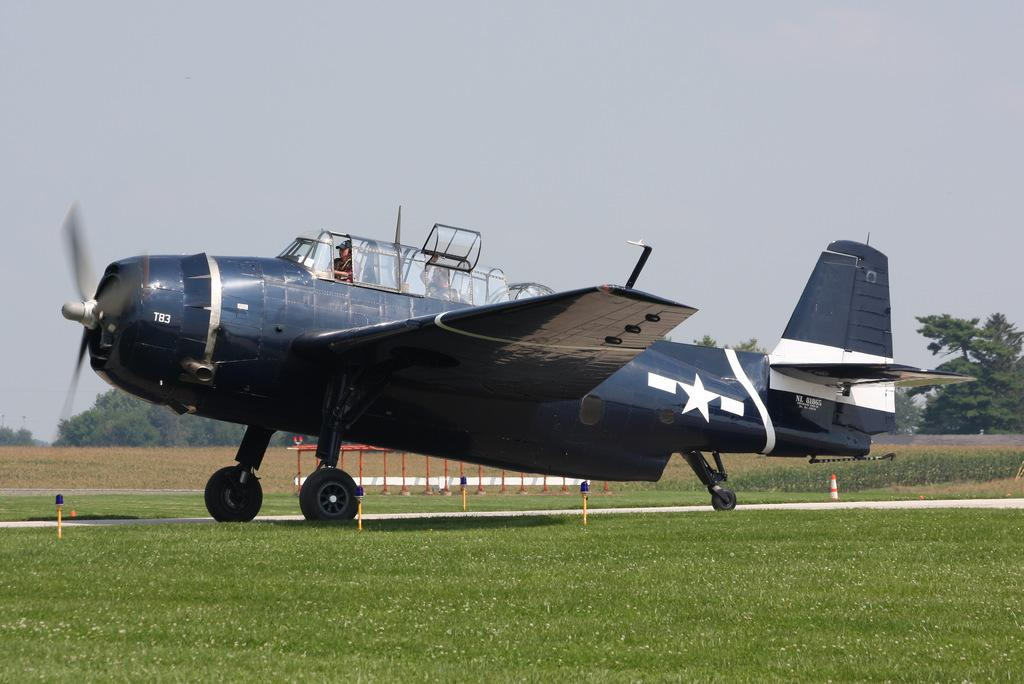Where is the person located in the image? The person is inside an airplane. What is the airplane's condition in the image? The airplane is on the surface. What type of vegetation can be seen in the image? There is grass visible in the image. What can be seen in the background of the image? There are trees and the sky visible in the background of the image. What type of drain is visible in the image? There is no drain present in the image. Where is the person going on vacation in the image? The image does not provide information about the person's vacation plans. 